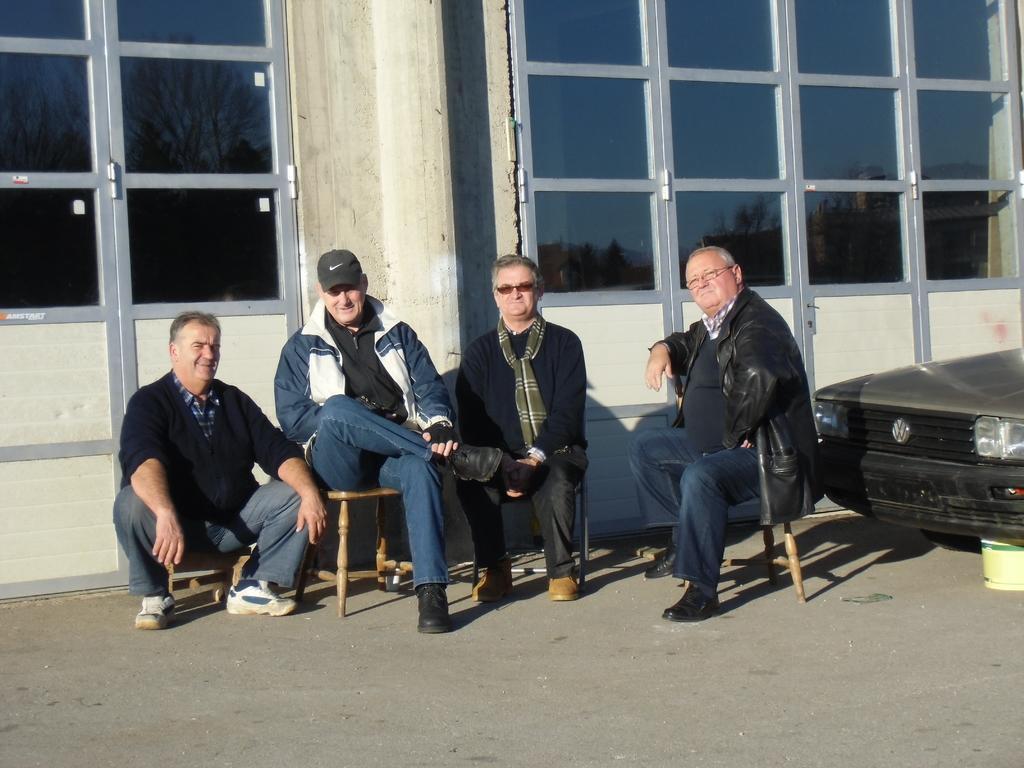Please provide a concise description of this image. In this picture, we see three men sitting on the chairs. The man in black jacket is sitting on the stool. All of them are smiling. Beside them, we see a black car is parked on the road. Behind them, we see a building. At the bottom of the picture, we see the sky and it is a sunny day. 